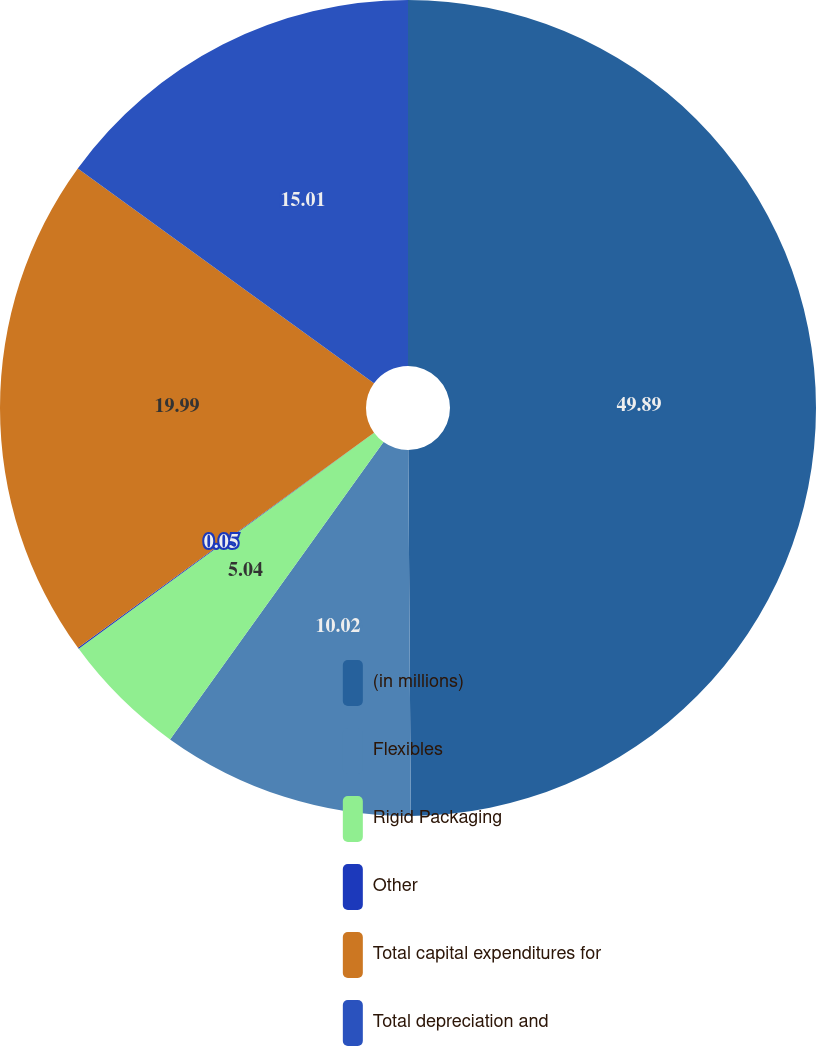Convert chart. <chart><loc_0><loc_0><loc_500><loc_500><pie_chart><fcel>(in millions)<fcel>Flexibles<fcel>Rigid Packaging<fcel>Other<fcel>Total capital expenditures for<fcel>Total depreciation and<nl><fcel>49.89%<fcel>10.02%<fcel>5.04%<fcel>0.05%<fcel>19.99%<fcel>15.01%<nl></chart> 